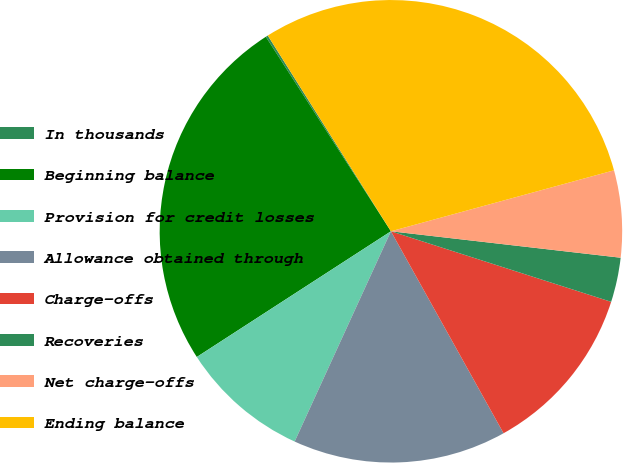Convert chart to OTSL. <chart><loc_0><loc_0><loc_500><loc_500><pie_chart><fcel>In thousands<fcel>Beginning balance<fcel>Provision for credit losses<fcel>Allowance obtained through<fcel>Charge-offs<fcel>Recoveries<fcel>Net charge-offs<fcel>Ending balance<nl><fcel>0.16%<fcel>25.05%<fcel>9.02%<fcel>14.93%<fcel>11.97%<fcel>3.11%<fcel>6.07%<fcel>29.69%<nl></chart> 